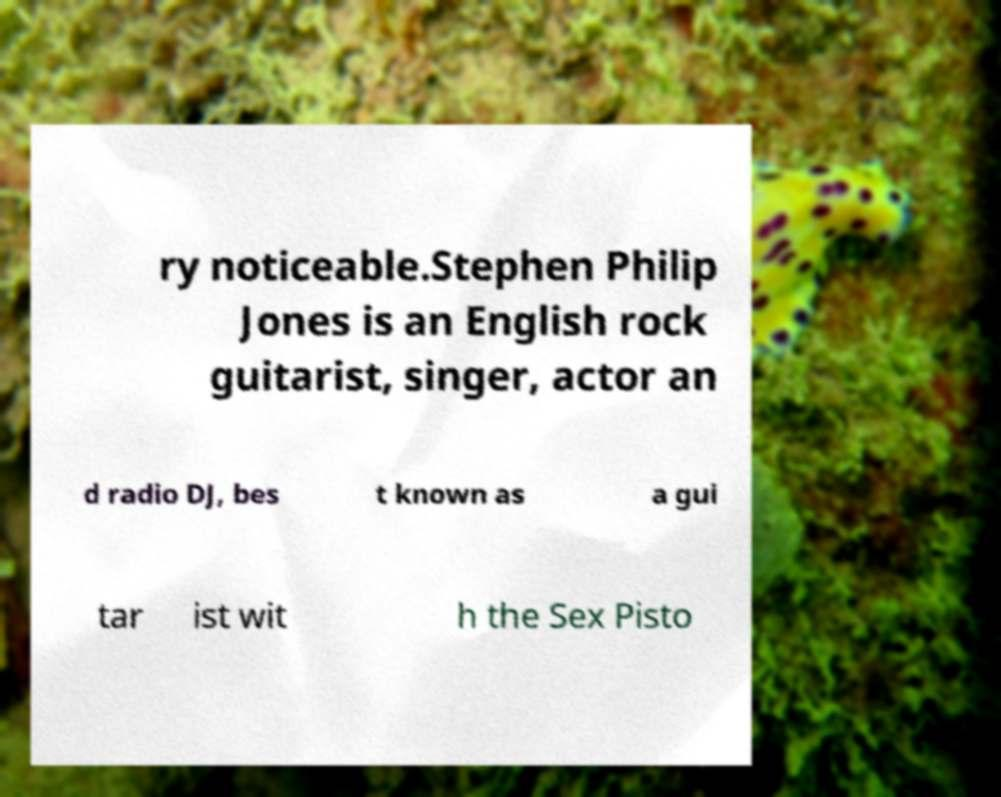Please identify and transcribe the text found in this image. ry noticeable.Stephen Philip Jones is an English rock guitarist, singer, actor an d radio DJ, bes t known as a gui tar ist wit h the Sex Pisto 